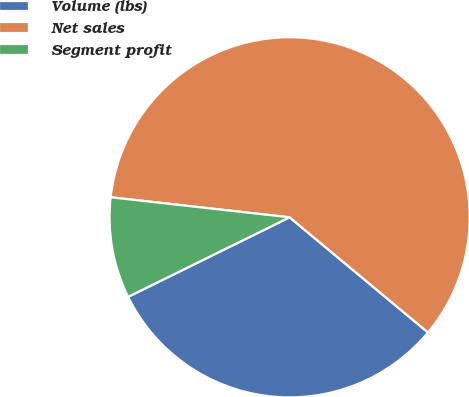Convert chart to OTSL. <chart><loc_0><loc_0><loc_500><loc_500><pie_chart><fcel>Volume (lbs)<fcel>Net sales<fcel>Segment profit<nl><fcel>31.67%<fcel>59.27%<fcel>9.06%<nl></chart> 